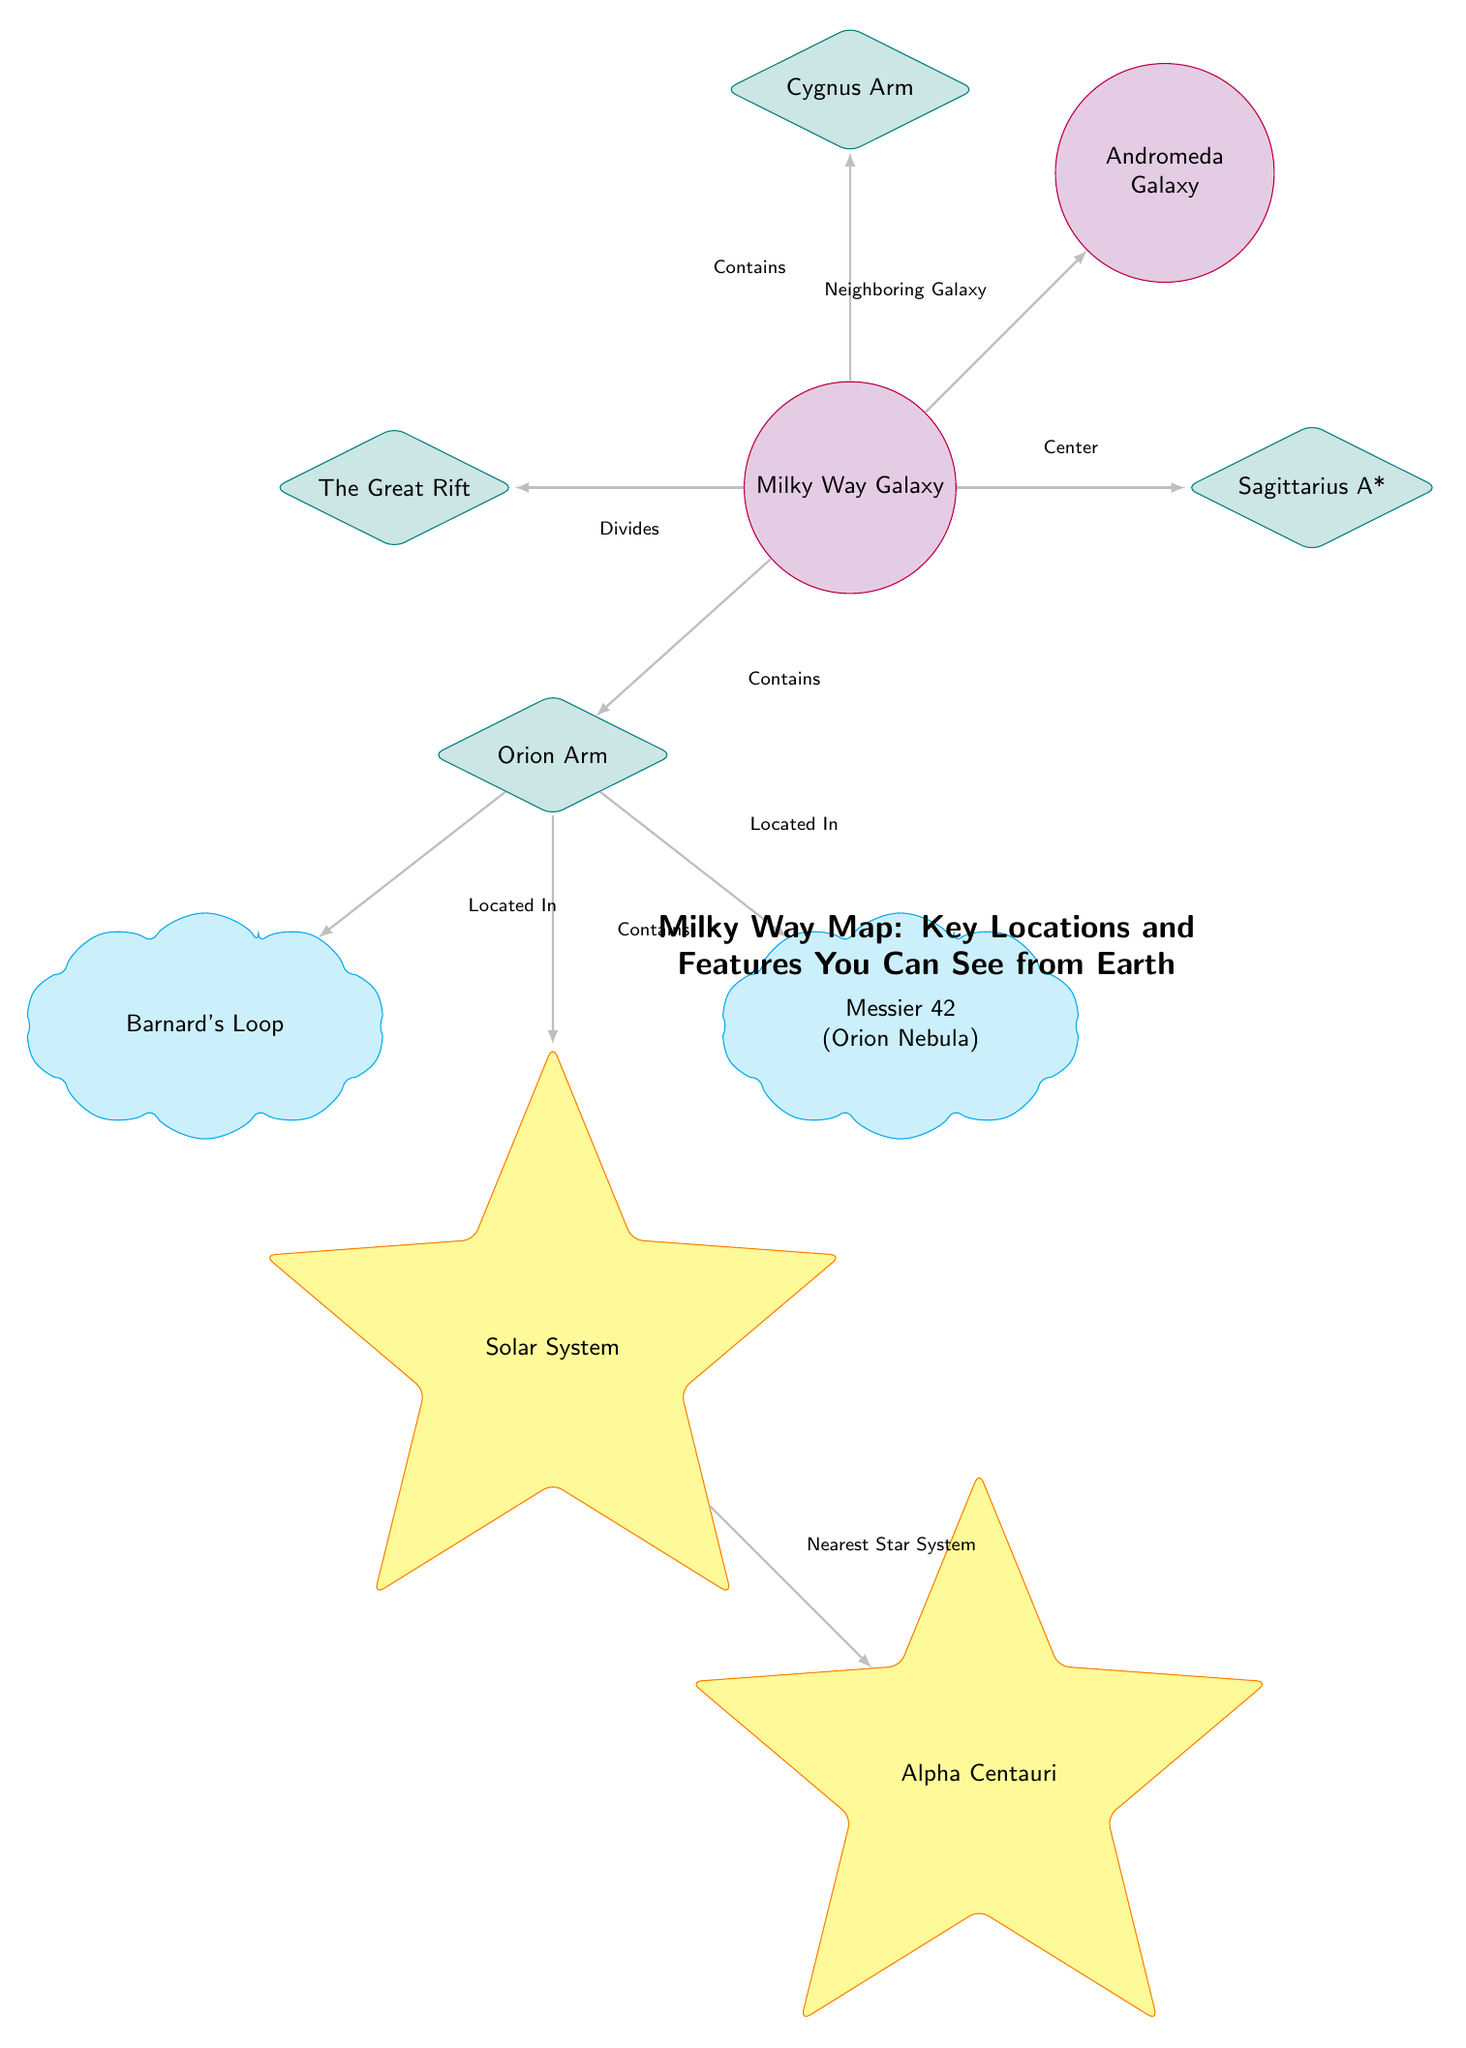What is the name of the galaxy represented at the center of the diagram? The central node in the diagram is labeled "Milky Way Galaxy," indicating that it is the main subject of the diagram.
Answer: Milky Way Galaxy Which arm of the Milky Way contains the Solar System? The Solar System is positioned under the "Orion Arm" in the diagram, indicating its location within the Milky Way.
Answer: Orion Arm What is the nearest star system to the Solar System according to the diagram? The diagram indicates that the "Solar System" node has a direct connection pointing to "Alpha Centauri," which is labeled as the nearest star system.
Answer: Alpha Centauri How many nebulas are identified in the diagram? There are two nebula nodes in the diagram: "Barnard's Loop" and "Messier 42 (Orion Nebula)," making the total count two.
Answer: 2 What does the Milky Way divide according to the diagram? The diagram shows an arrow labeled "Divides" from the "Milky Way Galaxy" node to "The Great Rift," indicating that the Great Rift is divided by the Milky Way.
Answer: The Great Rift Which galaxy is listed as a neighboring galaxy to the Milky Way? The diagram explicitly connects the "Milky Way Galaxy" to "Andromeda Galaxy" with an arrow labeled "Neighboring Galaxy," indicating their proximity.
Answer: Andromeda Galaxy In what position relative to the Milky Way Galaxy is Sagittarius A*? The "Sagittarius A*" node is positioned directly to the right of the "Milky Way Galaxy" node, indicating it is located on the eastern side.
Answer: Right Which two features are located within the Orion Arm? The Orion Arm contains both "Solar System" and "Barnard's Loop," as indicated by their connections in the diagram.
Answer: Solar System, Barnard's Loop How are the Cygnus Arm and the Milky Way Galaxy connected? The "Cygnus Arm" is shown as a feature that is connected to the "Milky Way Galaxy" node with an arrow labeled "Contains," indicating its inclusion within the galaxy.
Answer: Contains 